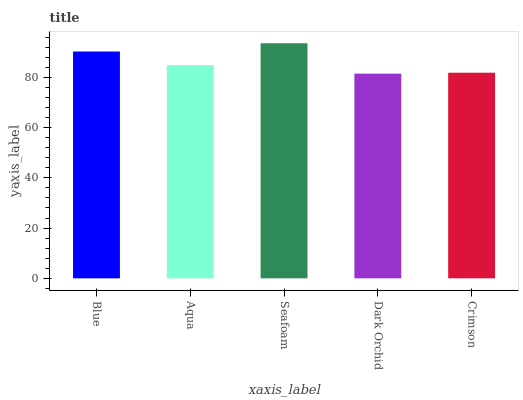Is Dark Orchid the minimum?
Answer yes or no. Yes. Is Seafoam the maximum?
Answer yes or no. Yes. Is Aqua the minimum?
Answer yes or no. No. Is Aqua the maximum?
Answer yes or no. No. Is Blue greater than Aqua?
Answer yes or no. Yes. Is Aqua less than Blue?
Answer yes or no. Yes. Is Aqua greater than Blue?
Answer yes or no. No. Is Blue less than Aqua?
Answer yes or no. No. Is Aqua the high median?
Answer yes or no. Yes. Is Aqua the low median?
Answer yes or no. Yes. Is Dark Orchid the high median?
Answer yes or no. No. Is Crimson the low median?
Answer yes or no. No. 